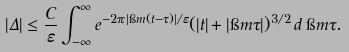<formula> <loc_0><loc_0><loc_500><loc_500>| \Delta | \leq \frac { C } \varepsilon \int _ { - \infty } ^ { \infty } e ^ { - 2 \pi | \i m ( t - \tau ) | / \varepsilon } ( | t | + | \i m \tau | ) ^ { 3 / 2 } \, d \, \i m \tau .</formula> 